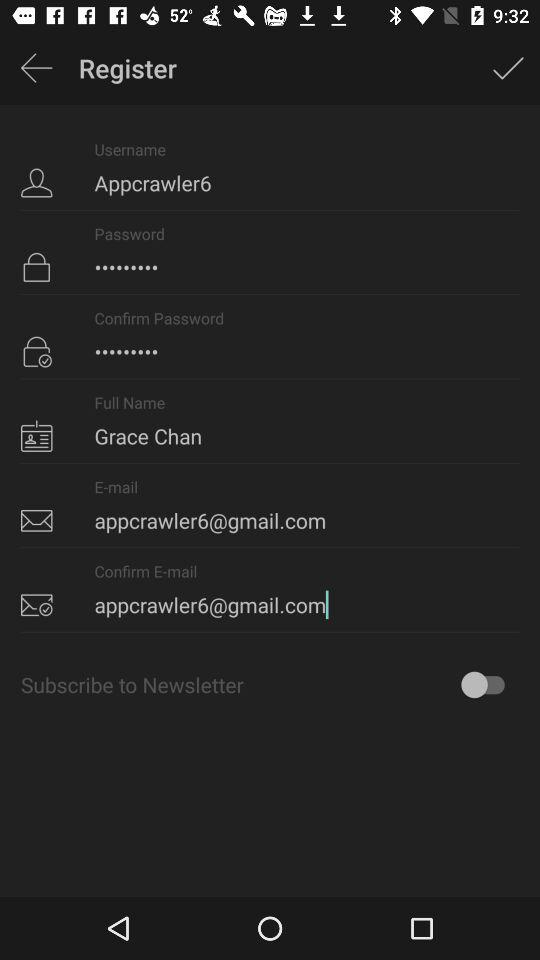What is the email address? The email address is appcrawler6@gmail.com. 